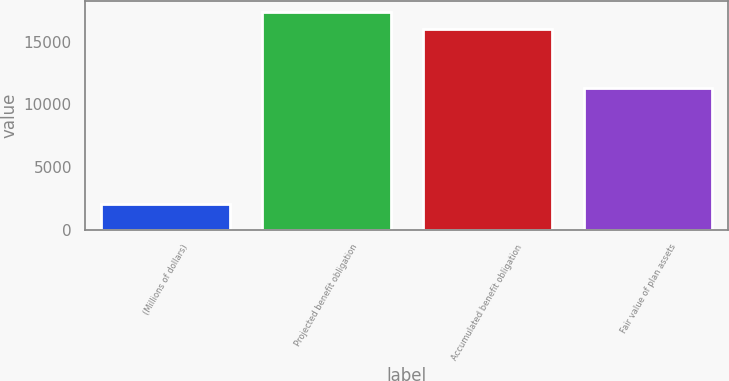Convert chart to OTSL. <chart><loc_0><loc_0><loc_500><loc_500><bar_chart><fcel>(Millions of dollars)<fcel>Projected benefit obligation<fcel>Accumulated benefit obligation<fcel>Fair value of plan assets<nl><fcel>2016<fcel>17393.7<fcel>15979<fcel>11295<nl></chart> 